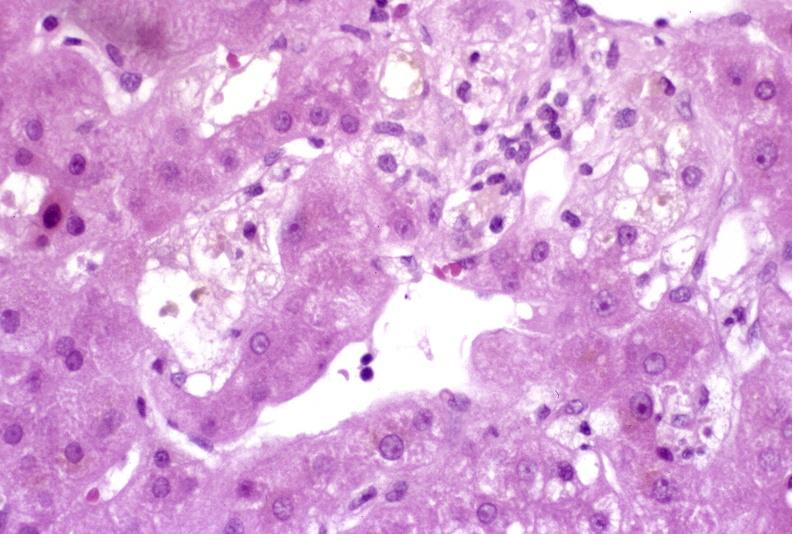s stein leventhal present?
Answer the question using a single word or phrase. No 